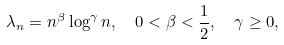<formula> <loc_0><loc_0><loc_500><loc_500>\lambda _ { n } & = n ^ { \beta } \log ^ { \gamma } n , \quad 0 < \beta < \frac { 1 } { 2 } , \quad \gamma \geq 0 ,</formula> 